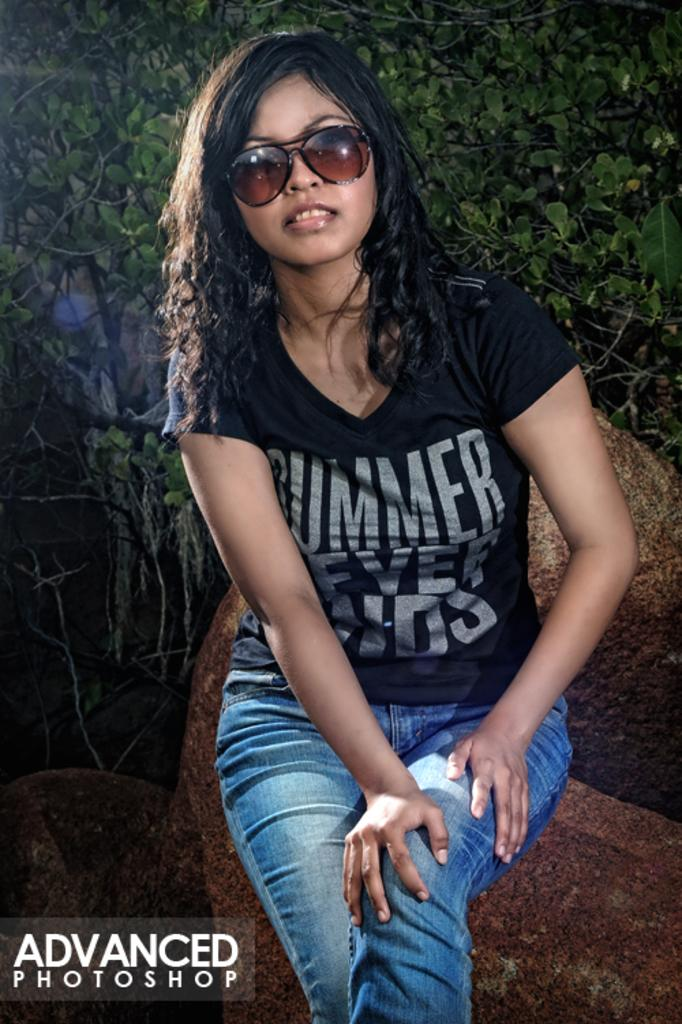What is the person in the image doing? The person is sitting in the image. What is the person wearing? The person is wearing a black t-shirt. What is the color of the person's hair? The person has black hair. What can be seen in the background of the image? There are leaves in the background of the image. What type of pencil is the person holding in the image? There is no pencil present in the image. What industry is depicted in the background of the image? There is no industry visible in the image; only leaves can be seen in the background. 